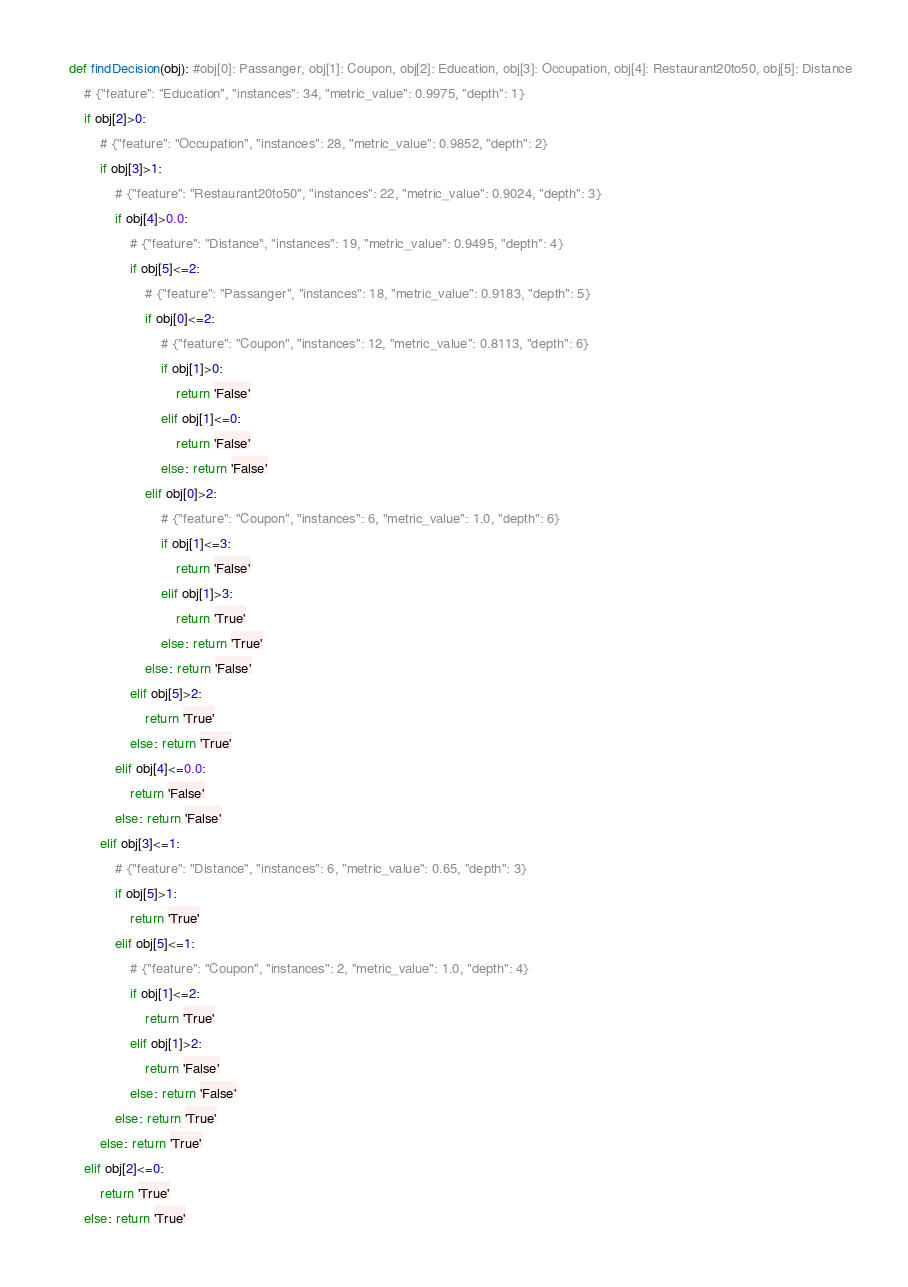Convert code to text. <code><loc_0><loc_0><loc_500><loc_500><_Python_>def findDecision(obj): #obj[0]: Passanger, obj[1]: Coupon, obj[2]: Education, obj[3]: Occupation, obj[4]: Restaurant20to50, obj[5]: Distance
	# {"feature": "Education", "instances": 34, "metric_value": 0.9975, "depth": 1}
	if obj[2]>0:
		# {"feature": "Occupation", "instances": 28, "metric_value": 0.9852, "depth": 2}
		if obj[3]>1:
			# {"feature": "Restaurant20to50", "instances": 22, "metric_value": 0.9024, "depth": 3}
			if obj[4]>0.0:
				# {"feature": "Distance", "instances": 19, "metric_value": 0.9495, "depth": 4}
				if obj[5]<=2:
					# {"feature": "Passanger", "instances": 18, "metric_value": 0.9183, "depth": 5}
					if obj[0]<=2:
						# {"feature": "Coupon", "instances": 12, "metric_value": 0.8113, "depth": 6}
						if obj[1]>0:
							return 'False'
						elif obj[1]<=0:
							return 'False'
						else: return 'False'
					elif obj[0]>2:
						# {"feature": "Coupon", "instances": 6, "metric_value": 1.0, "depth": 6}
						if obj[1]<=3:
							return 'False'
						elif obj[1]>3:
							return 'True'
						else: return 'True'
					else: return 'False'
				elif obj[5]>2:
					return 'True'
				else: return 'True'
			elif obj[4]<=0.0:
				return 'False'
			else: return 'False'
		elif obj[3]<=1:
			# {"feature": "Distance", "instances": 6, "metric_value": 0.65, "depth": 3}
			if obj[5]>1:
				return 'True'
			elif obj[5]<=1:
				# {"feature": "Coupon", "instances": 2, "metric_value": 1.0, "depth": 4}
				if obj[1]<=2:
					return 'True'
				elif obj[1]>2:
					return 'False'
				else: return 'False'
			else: return 'True'
		else: return 'True'
	elif obj[2]<=0:
		return 'True'
	else: return 'True'
</code> 